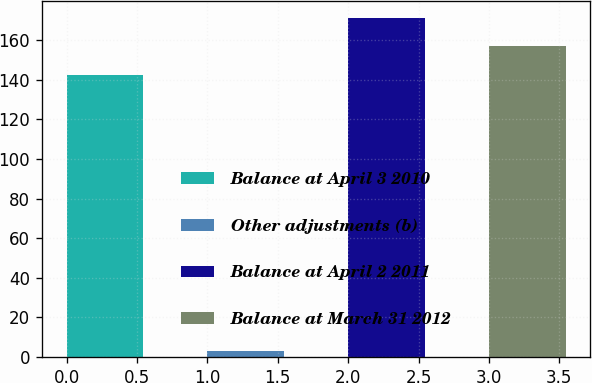<chart> <loc_0><loc_0><loc_500><loc_500><bar_chart><fcel>Balance at April 3 2010<fcel>Other adjustments (b)<fcel>Balance at April 2 2011<fcel>Balance at March 31 2012<nl><fcel>142.5<fcel>3.3<fcel>171<fcel>156.75<nl></chart> 